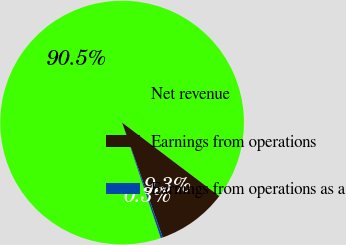Convert chart to OTSL. <chart><loc_0><loc_0><loc_500><loc_500><pie_chart><fcel>Net revenue<fcel>Earnings from operations<fcel>Earnings from operations as a<nl><fcel>90.46%<fcel>9.28%<fcel>0.26%<nl></chart> 